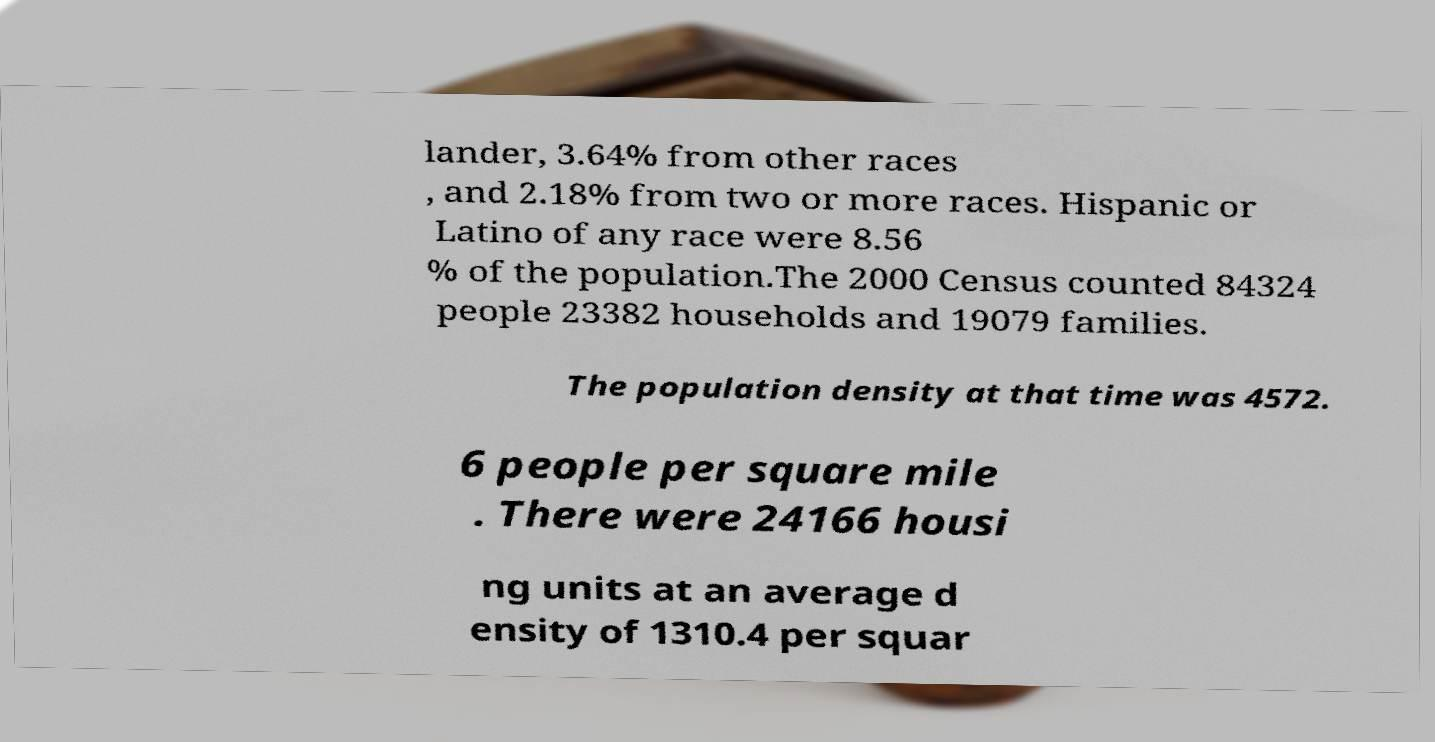What messages or text are displayed in this image? I need them in a readable, typed format. lander, 3.64% from other races , and 2.18% from two or more races. Hispanic or Latino of any race were 8.56 % of the population.The 2000 Census counted 84324 people 23382 households and 19079 families. The population density at that time was 4572. 6 people per square mile . There were 24166 housi ng units at an average d ensity of 1310.4 per squar 